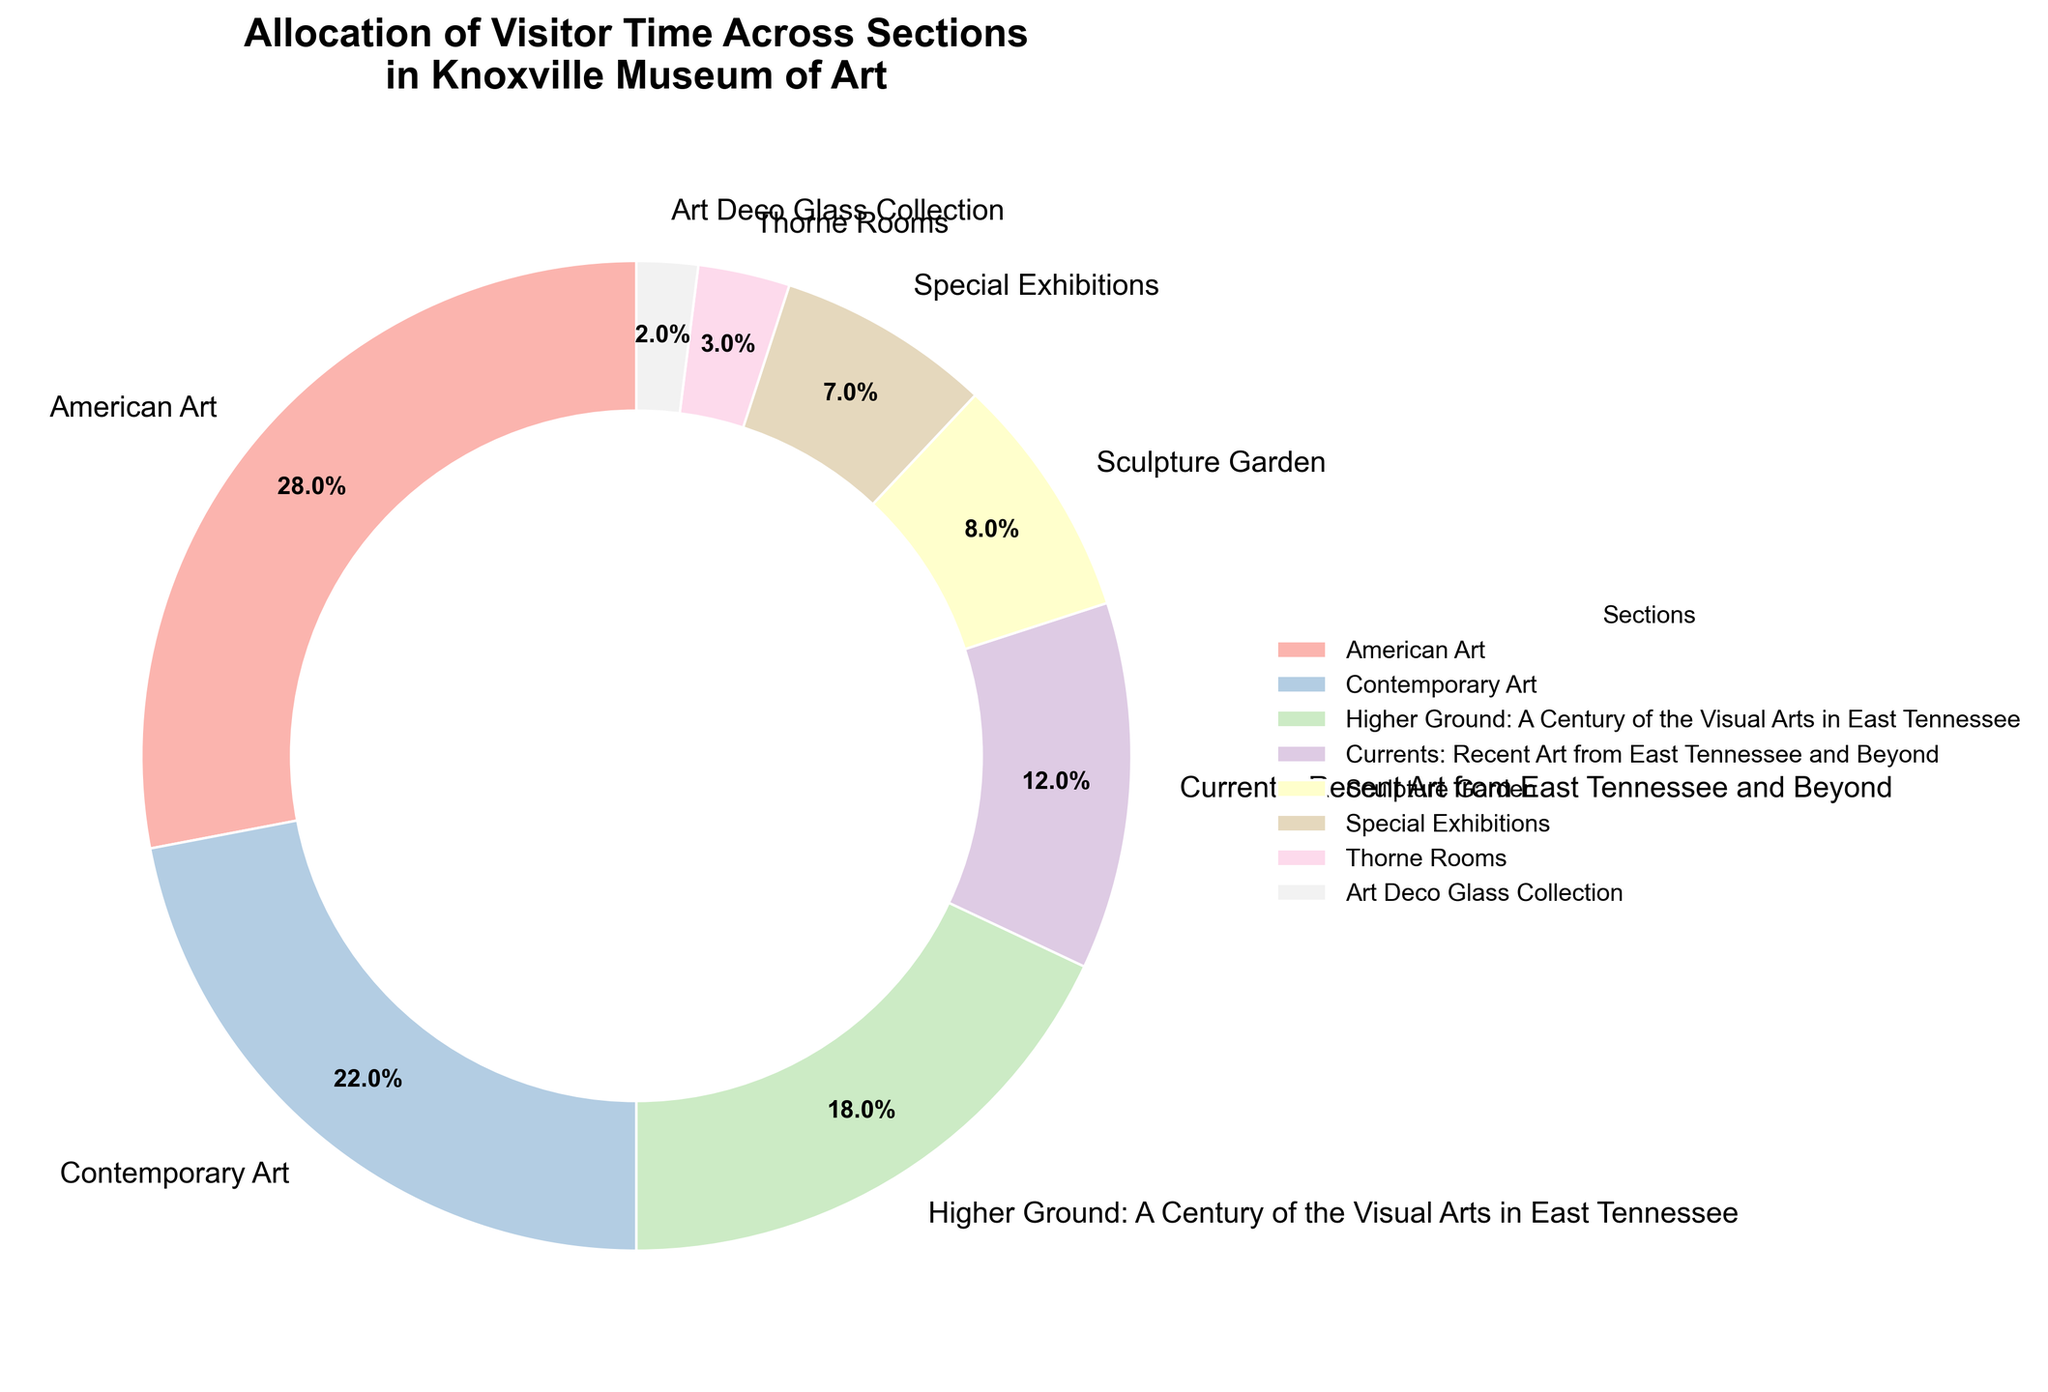What's the total percentage of time visitors spend in the "Higher Ground" and "Currents" sections together? To find the total percentage, add the percentages of the "Higher Ground: A Century of the Visual Arts in East Tennessee" section (18%) and the "Currents: Recent Art from East Tennessee and Beyond" section (12%). So, 18% + 12% = 30%.
Answer: 30% Which section occupies the smallest percentage of visitor time? The section with the smallest percentage is the "Art Deco Glass Collection" with 2%.
Answer: Art Deco Glass Collection How much more time do visitors spend in the "American Art" section compared to the "Sculpture Garden" section? Subtract the percentage of time spent in "Sculpture Garden" (8%) from the percentage of time spent in "American Art" (28%). So, 28% - 8% = 20%.
Answer: 20% Rank the sections in descending order of visitor time allocation. List the sections by their percentages in descending order: American Art (28%), Contemporary Art (22%), Higher Ground: A Century of the Visual Arts in East Tennessee (18%), Currents: Recent Art from East Tennessee and Beyond (12%), Sculpture Garden (8%), Special Exhibitions (7%), Thorne Rooms (3%), Art Deco Glass Collection (2%).
Answer: American Art, Contemporary Art, Higher Ground: A Century of the Visual Arts in East Tennessee, Currents: Recent Art from East Tennessee and Beyond, Sculpture Garden, Special Exhibitions, Thorne Rooms, Art Deco Glass Collection What is the difference in the percentage of time spent by visitors in "Contemporary Art" and "Special Exhibitions"? Subtract the percentage of time spent in "Special Exhibitions" (7%) from the percentage of time spent in "Contemporary Art" (22%). So, 22% - 7% = 15%.
Answer: 15% By how much does the percentage of visitor time in "Higher Ground" exceed that of "Thorne Rooms"? Subtract the percentage of time spent in the "Thorne Rooms" (3%) from "Higher Ground: A Century of the Visual Arts in East Tennessee" (18%). So, 18% - 3% = 15%.
Answer: 15% What percentage of visitor time is spent in sections other than "American Art"? Subtract the percentage of time spent in "American Art" (28%) from the total percentage (100%). So, 100% - 28% = 72%.
Answer: 72% Which section that has a percentage below 10% gets the least visitor time? From the sections below 10% (Sculpture Garden, Special Exhibitions, Thorne Rooms, Art Deco Glass Collection), the section with the least visitor time is "Art Deco Glass Collection" at 2%.
Answer: Art Deco Glass Collection Compare the visitor time allocation for "Sculpture Garden" and "Special Exhibitions". Which one has more visitor time and by how much? "Sculpture Garden" has 8% and "Special Exhibitions" has 7%. Subtract 7% from 8% to find the difference. So, 8% - 7% = 1%.
Answer: Sculpture Garden; 1% more 